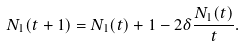Convert formula to latex. <formula><loc_0><loc_0><loc_500><loc_500>N _ { 1 } ( t + 1 ) = N _ { 1 } ( t ) + 1 - 2 \delta \frac { N _ { 1 } ( t ) } { t } .</formula> 